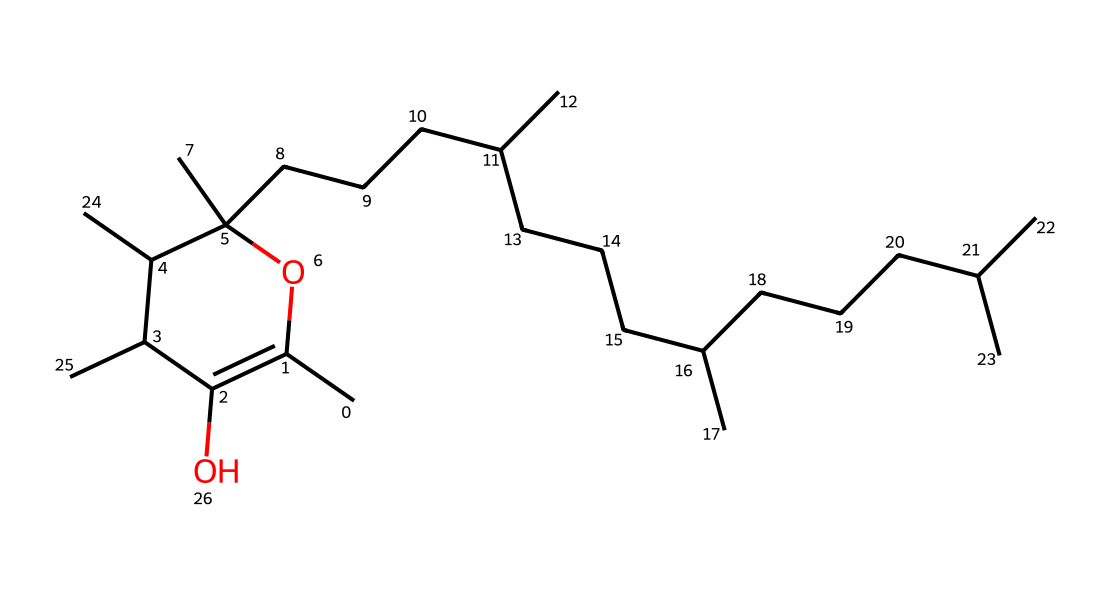What is the molecular formula of this compound? To determine the molecular formula, I count the number of each type of atom in the structure represented by the SMILES notation. The chemical structure has a total of 27 carbon (C) atoms, 46 hydrogen (H) atoms, and 2 oxygen (O) atoms, leading to the molecular formula C27H46O2.
Answer: C27H46O2 How many rings are present in this molecular structure? I analyze the chemical structure represented in SMILES to identify if there are any rings. The "C1" notation indicates a cyclic structure starting and ending with "C". After careful examination, I determine there is one ring in the structure.
Answer: 1 What type of functional groups are present in this structure? I look at the distinctive features of the molecular structure. In this case, I identify hydroxyl (-OH) groups based on the presence of oxygen directly connected to carbon and a hydrogen atom, which indicates the presence of alcohol functional groups. There are two hydroxyl groups in the compound.
Answer: hydroxyl groups What role does this molecule primarily serve in biological systems? I consider the known biological functions of structures like this one, which displays characteristics of vitamin E. Vitamin E is recognized for its role in acting as an antioxidant and scavenging free radicals, which helps maintain cellular membrane integrity.
Answer: antioxidant What property of vitamin E allows it to scavenge free radicals effectively? I analyze the molecular structure to determine how its composition allows for free radical scavenging. The presence of the hydroxyl groups allows this molecule to donate hydrogen atoms to free radicals, thus neutralizing them. This ability of hydroxyl groups to stabilize radicals contributes to its antioxidant properties.
Answer: hydrogen donation Are there any stereocenters present in this molecule? I examine the structure to identify any carbon atoms bonded to four different substituents, which would indicate a stereocenter. In this specific molecule, I determine that there are multiple stereocenters due to its complex hydrocarbon structure.
Answer: yes 